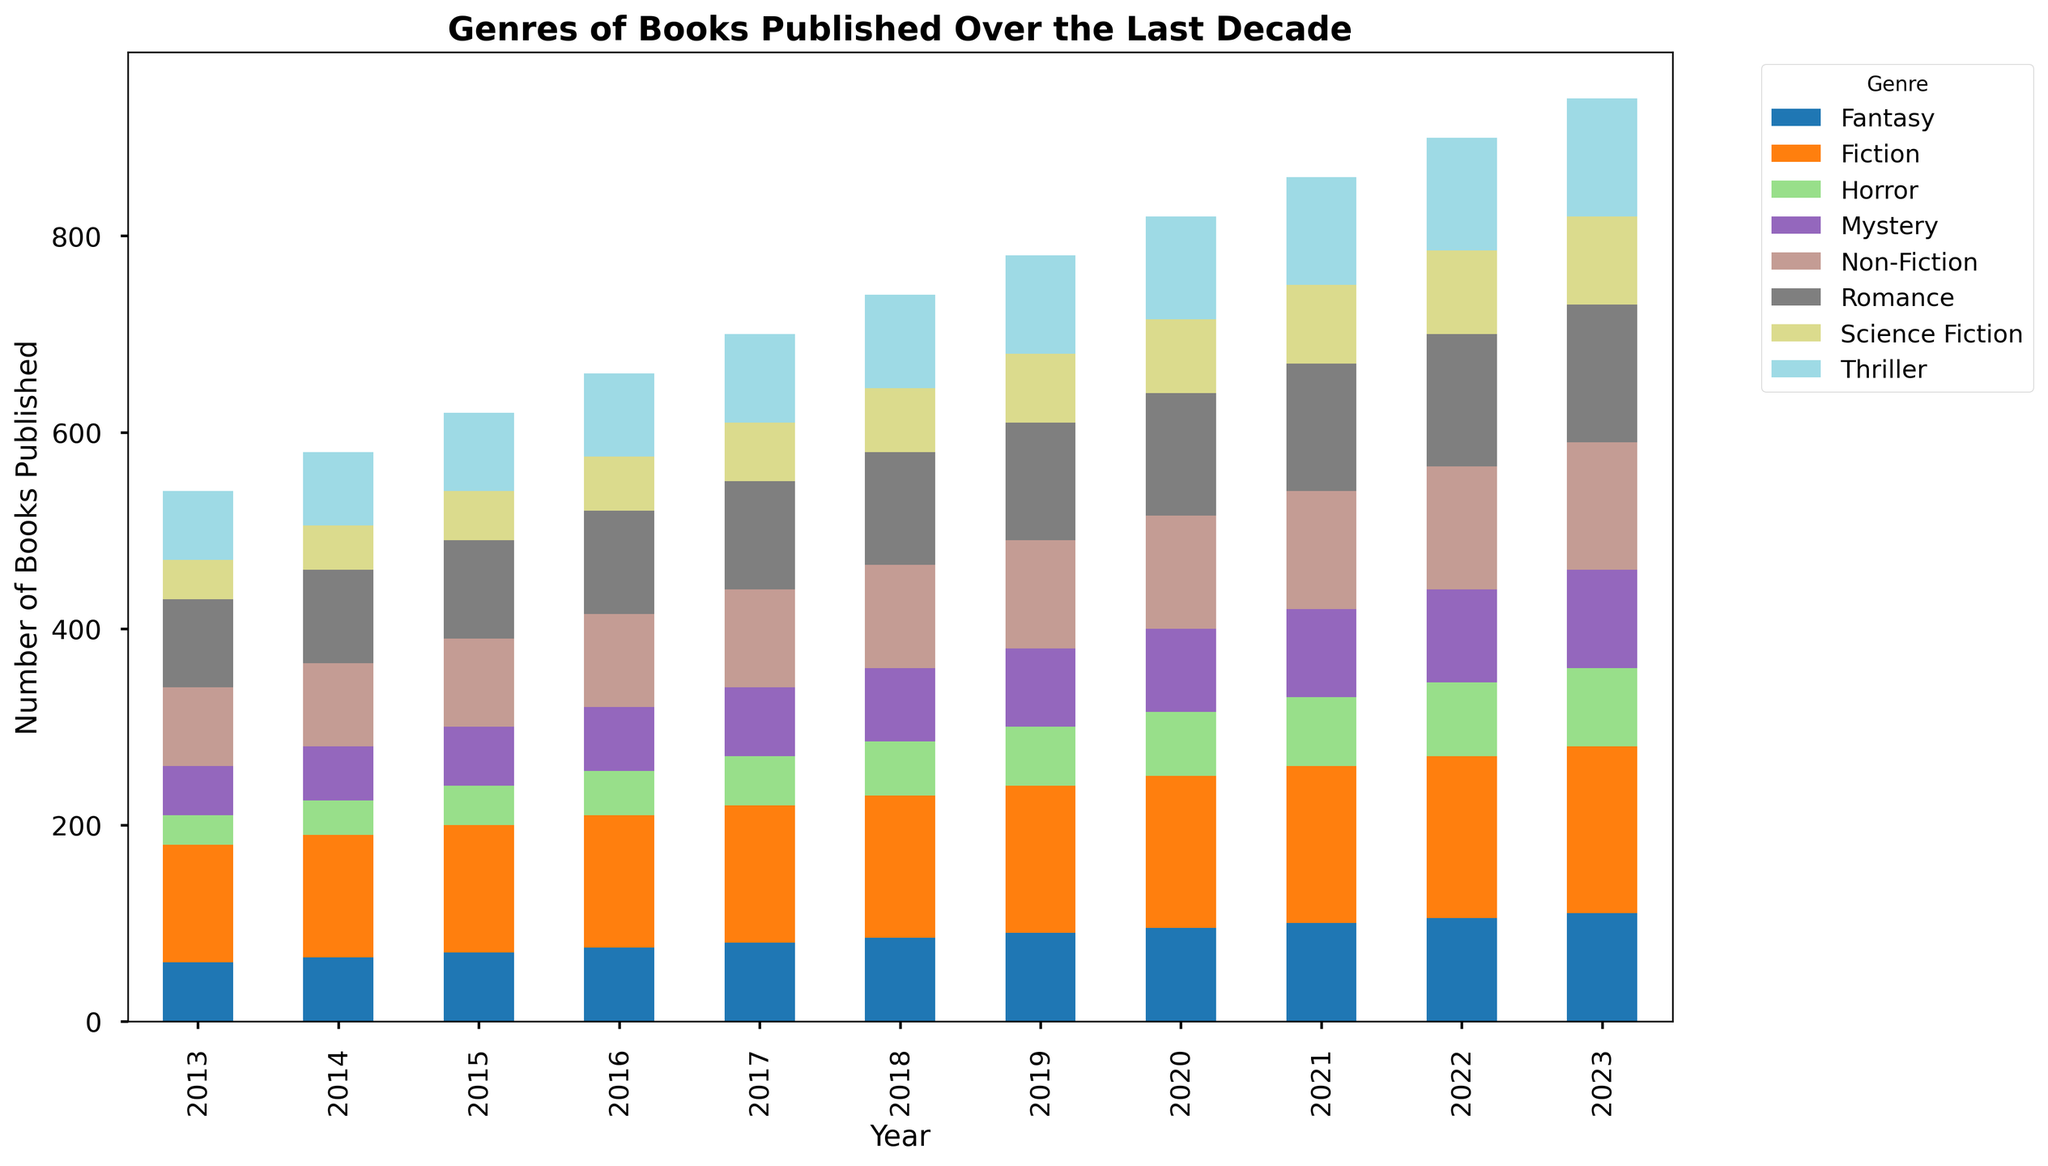Which genre had the highest number of books published in 2023? Look at the bar height for each genre in 2023 and identify the tallest bar. The bar for Fiction is the highest in 2023.
Answer: Fiction How many Fiction books were published in 2015 and 2020 combined? Look at the height of the Fiction bars for 2015 and 2020. The numbers are 130 and 155, respectively. Adding them together gives 130 + 155 = 285.
Answer: 285 Which year saw the highest total number of books published across all genres? Add up the heights for all genres for each year and compare them. The year 2023 has the highest total with 845 books published (170 + 130 + 100 + 120 + 90 + 110 + 140 + 80).
Answer: 2023 What is the average number of Science Fiction books published per year from 2013 to 2023? Sum the numbers for Science Fiction from 2013 to 2023 and divide by the number of years. The total is 0 + 40 + 45 + 50 + 55 + 60 + 65 + 70 + 75 + 80 + 85 + 90 = 450. There are 11 years, so the average is 450 / 11 ≈ 40.9.
Answer: ~40.9 Which genre showed the most consistent growth in the number of books published over the decade? By observing the trend of bars across years, Romance consistently shows an increasing number of books published as each year progresses.
Answer: Romance How many more Non-Fiction books were published in 2023 than in 2013? Compare the heights of the Non-Fiction bars in 2023 and 2013. The numbers are 130 in 2023 and 80 in 2013, so 130 - 80 = 50.
Answer: 50 Which genre had the lowest number of books published across all years? Look at the bar heights across all years for each genre and find the lowest point. Horror consistently has the lowest number each year.
Answer: Horror What is the total number of Mystery books published from 2015 to 2020? Sum the number of books for Mystery from 2015 to 2020. The count is 60 (2015) + 65 (2016) + 70 (2017) + 75 (2018) + 80 (2019) + 85 (2020) = 435.
Answer: 435 